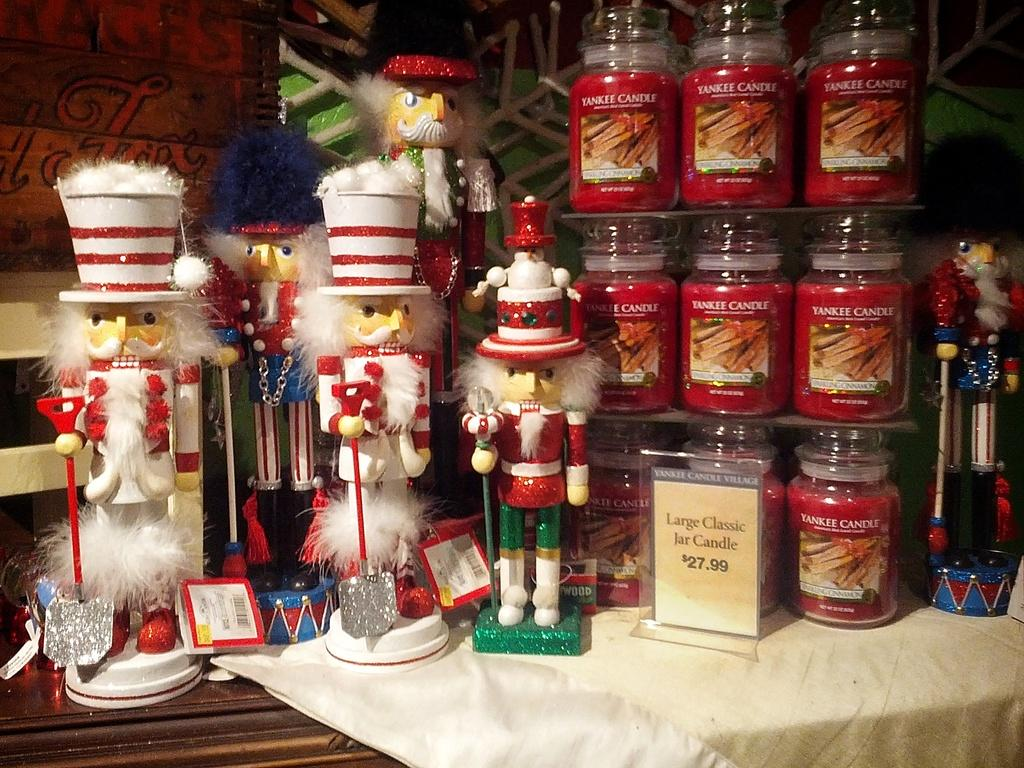Provide a one-sentence caption for the provided image. Wooden nutcrackers stand next to some red Yankee candles. 